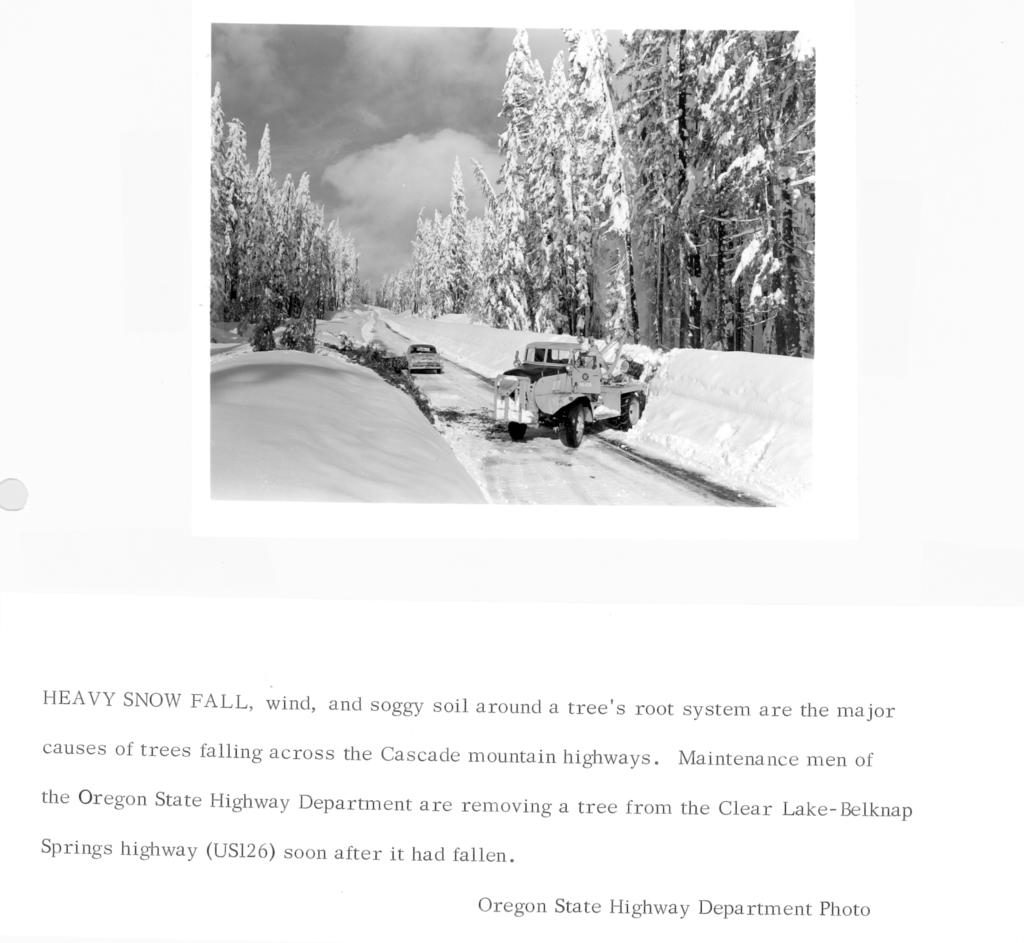What is the main subject of the image? The main subject of the image is a picture. What can be seen on the picture? There is text on the picture. What is the aftermath of the event depicted in the picture? There is no event depicted in the picture, as it only shows a picture with text on it. 